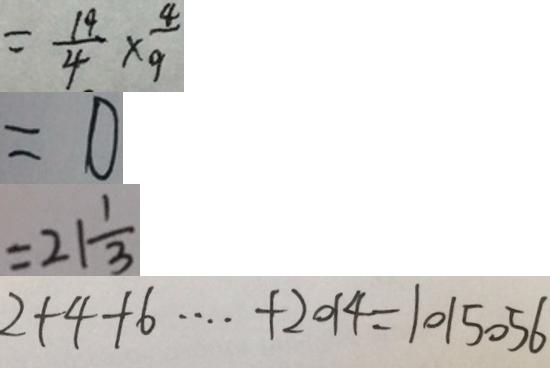<formula> <loc_0><loc_0><loc_500><loc_500>= \frac { 1 9 } { 4 } \times \frac { 4 } { 9 } 
 = 0 
 = 2 1 \frac { 1 } { 3 } 
 2 + 4 + 6 \cdots + 2 0 1 4 = 1 0 1 5 0 5 6</formula> 